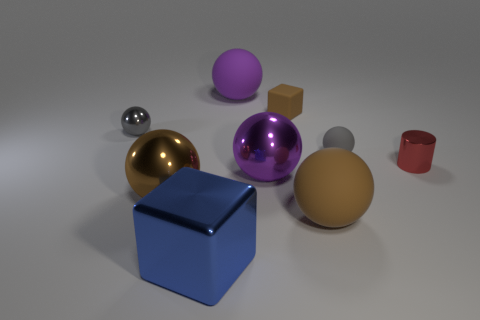How many big purple spheres are the same material as the blue thing?
Make the answer very short. 1. Are there fewer purple matte spheres on the right side of the tiny brown rubber cube than large red matte things?
Keep it short and to the point. No. How many metallic objects are there?
Offer a terse response. 5. How many objects have the same color as the small shiny sphere?
Offer a terse response. 1. Is the shape of the big purple matte object the same as the gray metallic thing?
Give a very brief answer. Yes. How big is the purple metal ball that is in front of the tiny metallic object right of the big purple metallic thing?
Offer a very short reply. Large. Is there a brown rubber thing of the same size as the gray shiny sphere?
Make the answer very short. Yes. Does the block that is behind the tiny red object have the same size as the brown rubber sphere right of the big blue block?
Offer a terse response. No. The tiny metal thing on the right side of the cube in front of the tiny red shiny cylinder is what shape?
Provide a short and direct response. Cylinder. There is a tiny rubber cube; what number of brown spheres are behind it?
Provide a succinct answer. 0. 